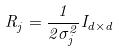Convert formula to latex. <formula><loc_0><loc_0><loc_500><loc_500>R _ { j } = \frac { 1 } { 2 \sigma _ { j } ^ { 2 } } I _ { d \times d }</formula> 